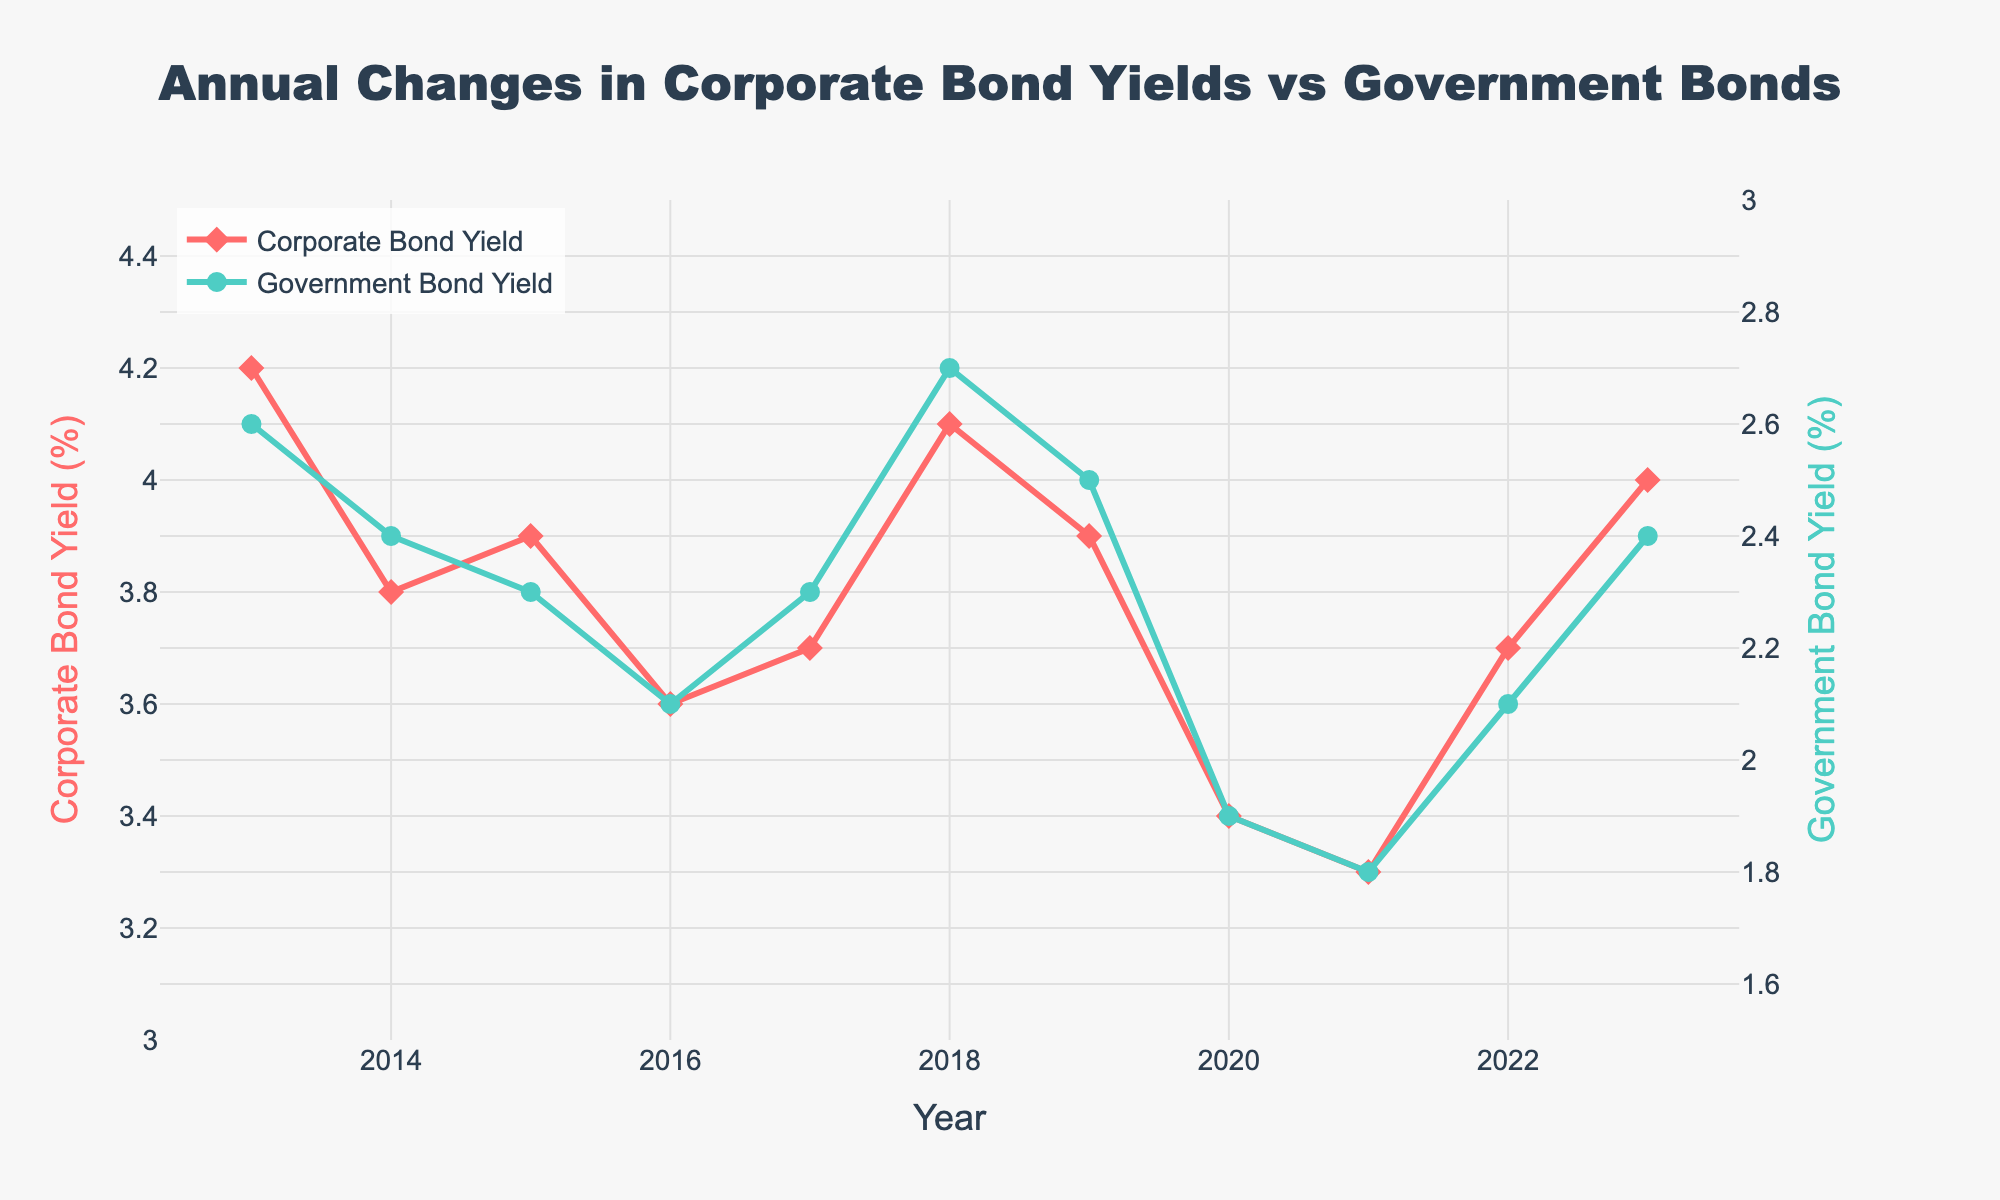What is the title of the plot? The title of the plot is prominently displayed at the top center of the figure, above the plotting area. It describes the main content of the plot in a concise manner.
Answer: Annual Changes in Corporate Bond Yields vs Government Bonds How many years of data are displayed in the plot? The x-axis represents the years, and the data points are plotted for each year. Count the number of distinct years from the x-axis.
Answer: 11 Which year shows the highest corporate bond yield? Look at the line representing the Corporate Bond Yield and find the peak value on the plot. Then, identify the corresponding year on the x-axis.
Answer: 2013 During which year did both the corporate bond yield and government bond yield experience an increase compared to the previous year? Observe both the lines representing Corporate Bond Yield and Government Bond Yield. Identify the year where both lines show an upward trend compared to the previous year.
Answer: 2018 What is the average government bond yield over the displayed years? Sum all the government bond yields presented in the plot and divide by the total number of years.
Answer: (2.6+2.4+2.3+2.1+2.3+2.7+2.5+1.9+1.8+2.1+2.4)/11 = 2.27 Which bond yield type showed a greater decrease in 2020 compared to 2019? Compare the changes in yield from 2019 to 2020 for both Corporate Bond Yield and Government Bond Yield. Calculate the differences and determine which is larger.
Answer: Corporate Bond Yield What is the difference between corporate bond yield and government bond yield in 2023? Find the yield values for 2023 from both Corporate Bond Yield and Government Bond Yield lines and subtract the Government Bond Yield from the Corporate Bond Yield.
Answer: 4.0 - 2.4 = 1.6 In which year did the corporate bond yield reach its lowest value? Identify the lowest point on the Corporate Bond Yield line and map it to the corresponding year on the x-axis.
Answer: 2021 How many times did the corporate bond yield fall below 3.6%? Observe the Corporate Bond Yield line and count the number of years where the yield value fell below the threshold of 3.6%.
Answer: 2 